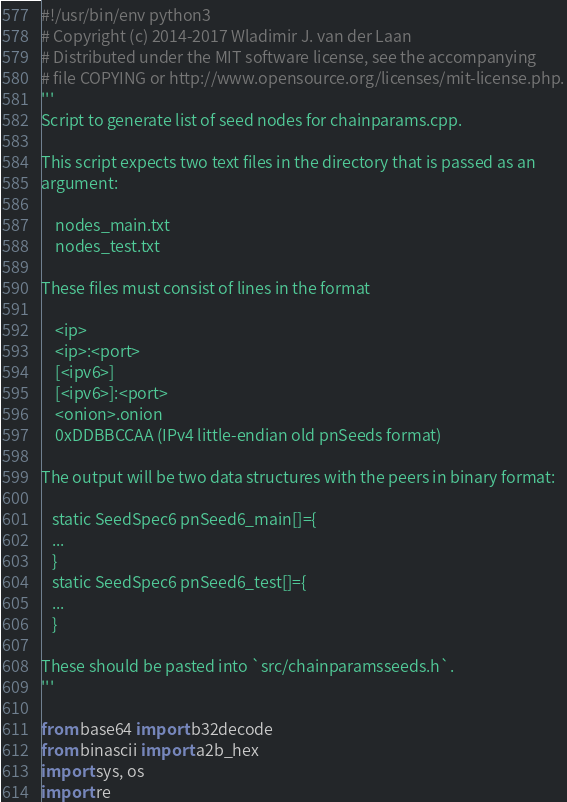<code> <loc_0><loc_0><loc_500><loc_500><_Python_>#!/usr/bin/env python3
# Copyright (c) 2014-2017 Wladimir J. van der Laan
# Distributed under the MIT software license, see the accompanying
# file COPYING or http://www.opensource.org/licenses/mit-license.php.
'''
Script to generate list of seed nodes for chainparams.cpp.

This script expects two text files in the directory that is passed as an
argument:

    nodes_main.txt
    nodes_test.txt

These files must consist of lines in the format

    <ip>
    <ip>:<port>
    [<ipv6>]
    [<ipv6>]:<port>
    <onion>.onion
    0xDDBBCCAA (IPv4 little-endian old pnSeeds format)

The output will be two data structures with the peers in binary format:

   static SeedSpec6 pnSeed6_main[]={
   ...
   }
   static SeedSpec6 pnSeed6_test[]={
   ...
   }

These should be pasted into `src/chainparamsseeds.h`.
'''

from base64 import b32decode
from binascii import a2b_hex
import sys, os
import re
</code> 